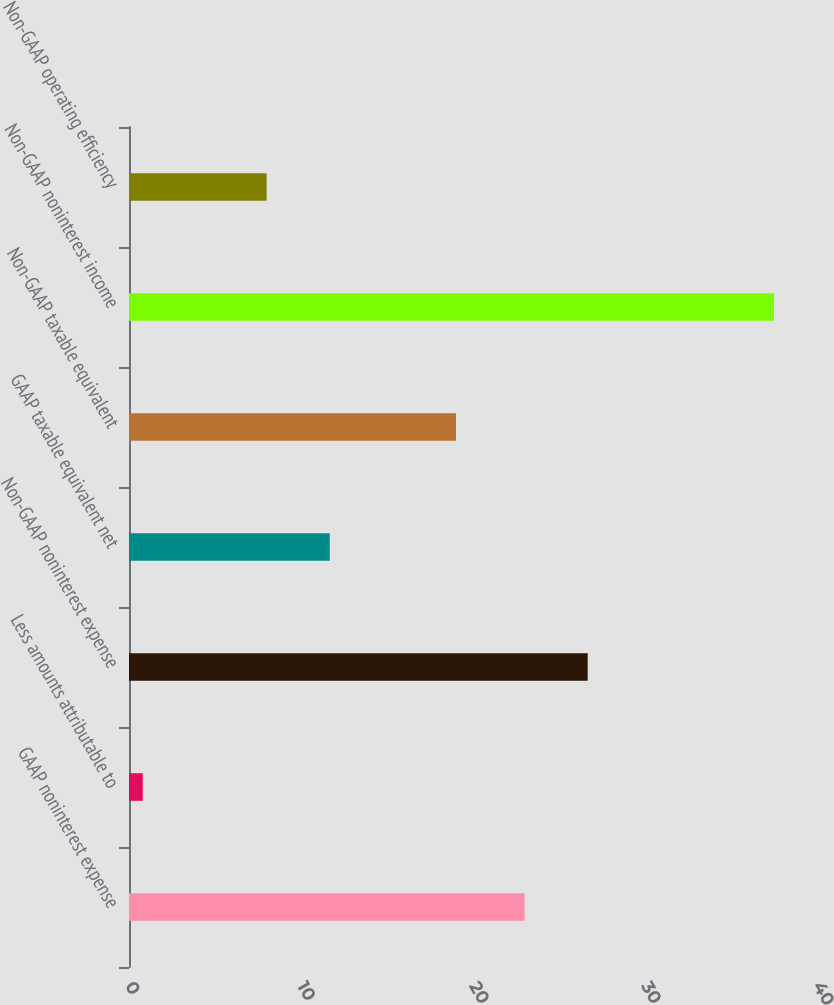Convert chart to OTSL. <chart><loc_0><loc_0><loc_500><loc_500><bar_chart><fcel>GAAP noninterest expense<fcel>Less amounts attributable to<fcel>Non-GAAP noninterest expense<fcel>GAAP taxable equivalent net<fcel>Non-GAAP taxable equivalent<fcel>Non-GAAP noninterest income<fcel>Non-GAAP operating efficiency<nl><fcel>23<fcel>0.8<fcel>26.67<fcel>11.67<fcel>19.01<fcel>37.5<fcel>8<nl></chart> 